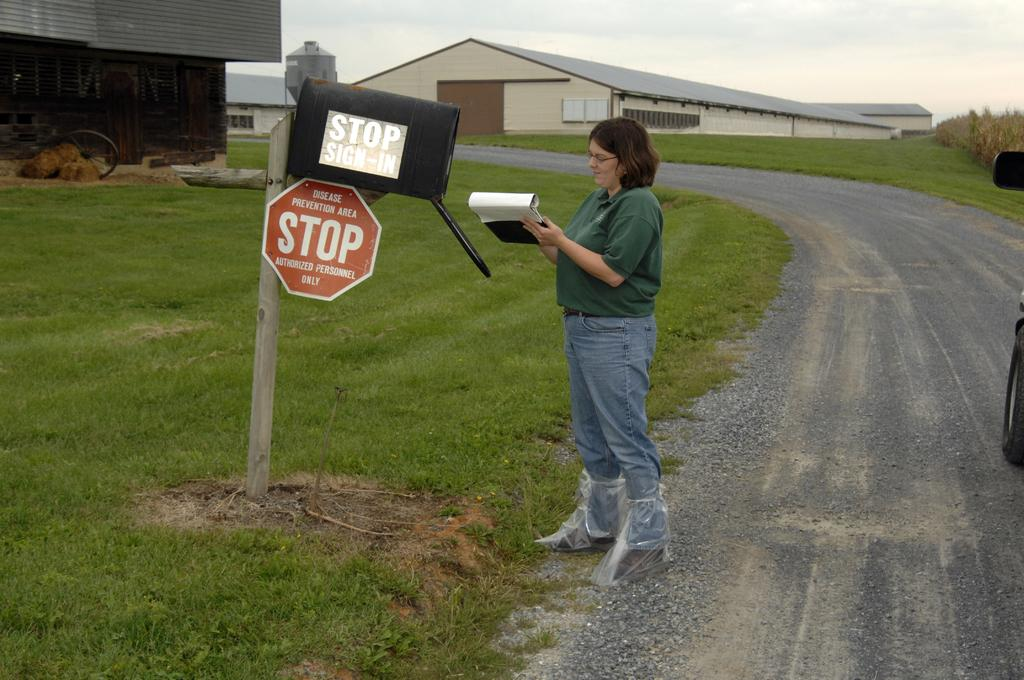<image>
Present a compact description of the photo's key features. A woman in a green shirt is standing in front of a mailbox with a stop sign on it, cautioning others of entering, signing a piece of paper. 